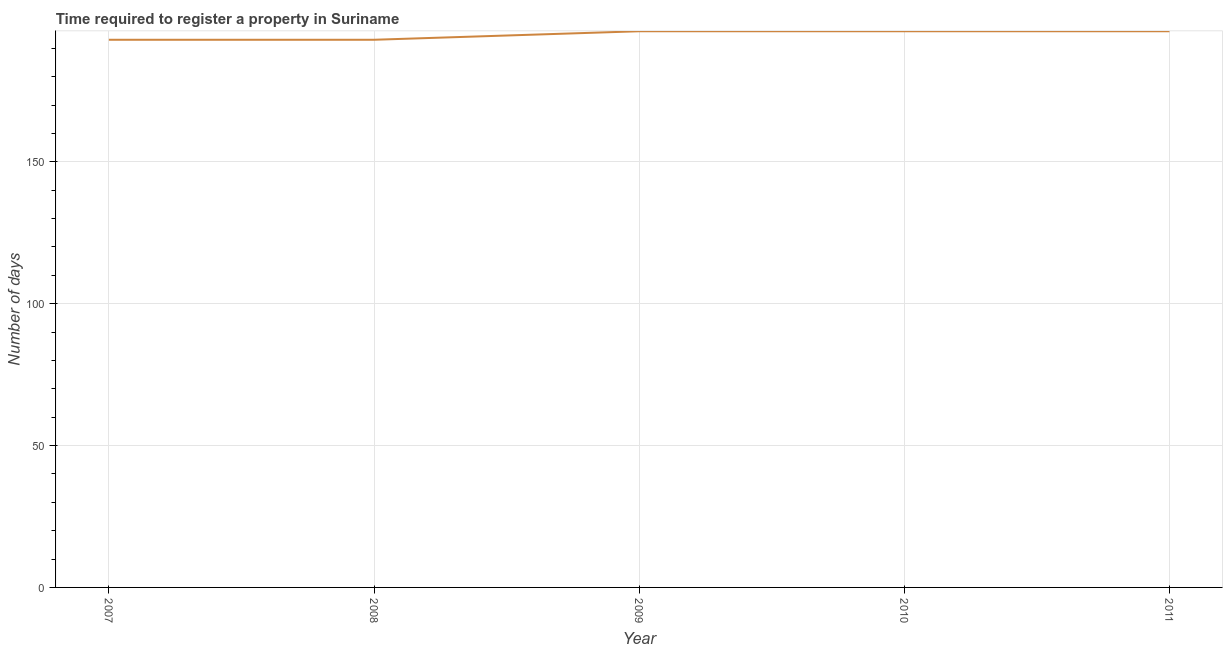What is the number of days required to register property in 2009?
Make the answer very short. 196. Across all years, what is the maximum number of days required to register property?
Offer a terse response. 196. Across all years, what is the minimum number of days required to register property?
Provide a succinct answer. 193. In which year was the number of days required to register property maximum?
Make the answer very short. 2009. In which year was the number of days required to register property minimum?
Your answer should be compact. 2007. What is the sum of the number of days required to register property?
Your answer should be compact. 974. What is the difference between the number of days required to register property in 2007 and 2011?
Give a very brief answer. -3. What is the average number of days required to register property per year?
Give a very brief answer. 194.8. What is the median number of days required to register property?
Your answer should be very brief. 196. Do a majority of the years between 2007 and 2008 (inclusive) have number of days required to register property greater than 30 days?
Give a very brief answer. Yes. What is the ratio of the number of days required to register property in 2007 to that in 2008?
Your answer should be very brief. 1. Is the number of days required to register property in 2008 less than that in 2011?
Offer a terse response. Yes. What is the difference between the highest and the second highest number of days required to register property?
Ensure brevity in your answer.  0. What is the difference between the highest and the lowest number of days required to register property?
Offer a terse response. 3. In how many years, is the number of days required to register property greater than the average number of days required to register property taken over all years?
Give a very brief answer. 3. Does the number of days required to register property monotonically increase over the years?
Provide a succinct answer. No. How many lines are there?
Your answer should be compact. 1. How many years are there in the graph?
Offer a very short reply. 5. Does the graph contain any zero values?
Your response must be concise. No. Does the graph contain grids?
Ensure brevity in your answer.  Yes. What is the title of the graph?
Give a very brief answer. Time required to register a property in Suriname. What is the label or title of the Y-axis?
Keep it short and to the point. Number of days. What is the Number of days in 2007?
Offer a terse response. 193. What is the Number of days in 2008?
Give a very brief answer. 193. What is the Number of days of 2009?
Your response must be concise. 196. What is the Number of days in 2010?
Provide a succinct answer. 196. What is the Number of days in 2011?
Your answer should be very brief. 196. What is the difference between the Number of days in 2007 and 2009?
Give a very brief answer. -3. What is the difference between the Number of days in 2007 and 2010?
Offer a very short reply. -3. What is the difference between the Number of days in 2007 and 2011?
Provide a succinct answer. -3. What is the difference between the Number of days in 2008 and 2011?
Your response must be concise. -3. What is the difference between the Number of days in 2009 and 2010?
Offer a very short reply. 0. What is the difference between the Number of days in 2010 and 2011?
Offer a very short reply. 0. What is the ratio of the Number of days in 2007 to that in 2008?
Give a very brief answer. 1. What is the ratio of the Number of days in 2007 to that in 2009?
Your response must be concise. 0.98. What is the ratio of the Number of days in 2007 to that in 2010?
Give a very brief answer. 0.98. What is the ratio of the Number of days in 2007 to that in 2011?
Offer a very short reply. 0.98. What is the ratio of the Number of days in 2008 to that in 2009?
Your answer should be very brief. 0.98. What is the ratio of the Number of days in 2008 to that in 2010?
Make the answer very short. 0.98. What is the ratio of the Number of days in 2009 to that in 2011?
Provide a succinct answer. 1. 